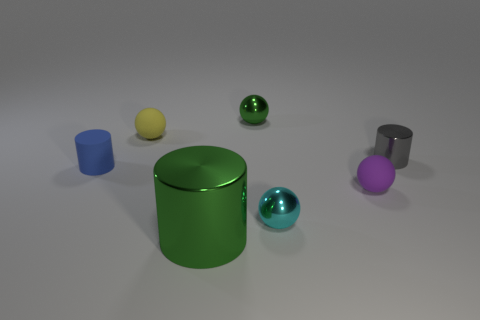Is there any other thing that has the same size as the green metal cylinder?
Your answer should be very brief. No. How big is the yellow rubber ball?
Ensure brevity in your answer.  Small. The other ball that is made of the same material as the tiny cyan sphere is what color?
Keep it short and to the point. Green. What number of tiny blue cylinders are made of the same material as the yellow thing?
Your response must be concise. 1. Is the color of the tiny metal cylinder the same as the shiny cylinder that is in front of the tiny cyan shiny thing?
Offer a very short reply. No. There is a ball on the left side of the metal ball behind the tiny blue thing; what is its color?
Your response must be concise. Yellow. The matte cylinder that is the same size as the yellow ball is what color?
Make the answer very short. Blue. Are there any purple metal things of the same shape as the big green metal object?
Ensure brevity in your answer.  No. What is the shape of the blue object?
Ensure brevity in your answer.  Cylinder. Is the number of gray metal objects that are in front of the tiny blue cylinder greater than the number of small gray objects that are on the left side of the small yellow rubber thing?
Make the answer very short. No. 